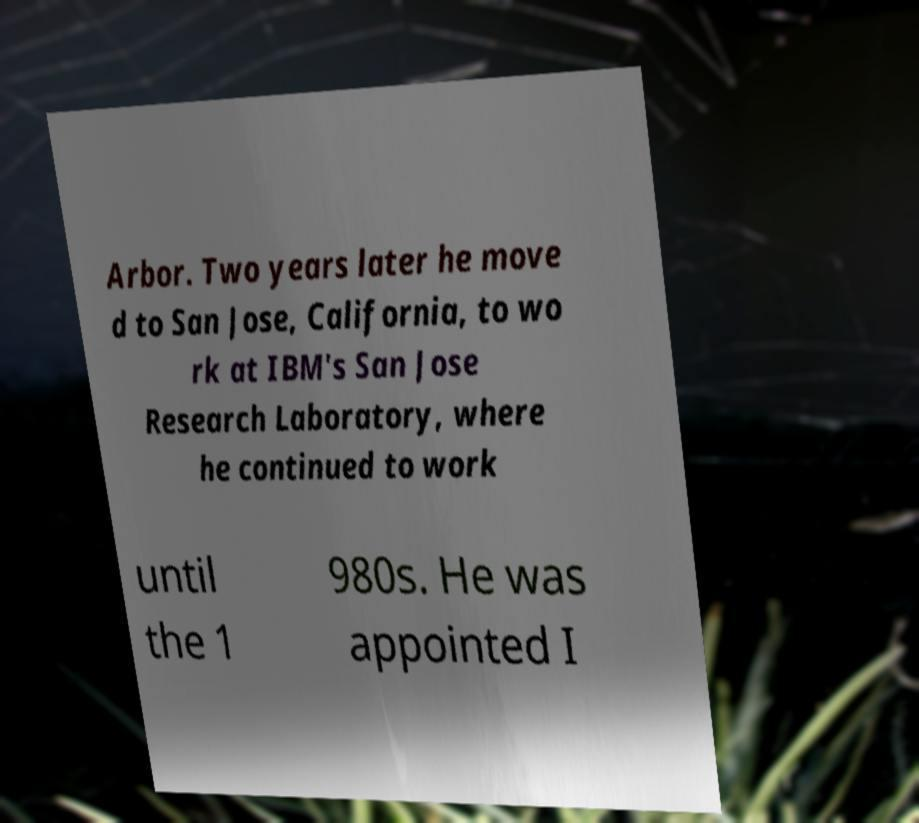What messages or text are displayed in this image? I need them in a readable, typed format. Arbor. Two years later he move d to San Jose, California, to wo rk at IBM's San Jose Research Laboratory, where he continued to work until the 1 980s. He was appointed I 